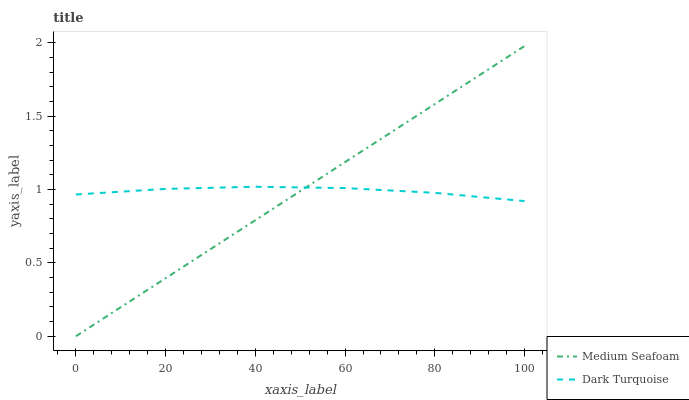Does Medium Seafoam have the minimum area under the curve?
Answer yes or no. Yes. Does Dark Turquoise have the maximum area under the curve?
Answer yes or no. Yes. Does Medium Seafoam have the maximum area under the curve?
Answer yes or no. No. Is Medium Seafoam the smoothest?
Answer yes or no. Yes. Is Dark Turquoise the roughest?
Answer yes or no. Yes. Is Medium Seafoam the roughest?
Answer yes or no. No. Does Medium Seafoam have the lowest value?
Answer yes or no. Yes. Does Medium Seafoam have the highest value?
Answer yes or no. Yes. Does Medium Seafoam intersect Dark Turquoise?
Answer yes or no. Yes. Is Medium Seafoam less than Dark Turquoise?
Answer yes or no. No. Is Medium Seafoam greater than Dark Turquoise?
Answer yes or no. No. 